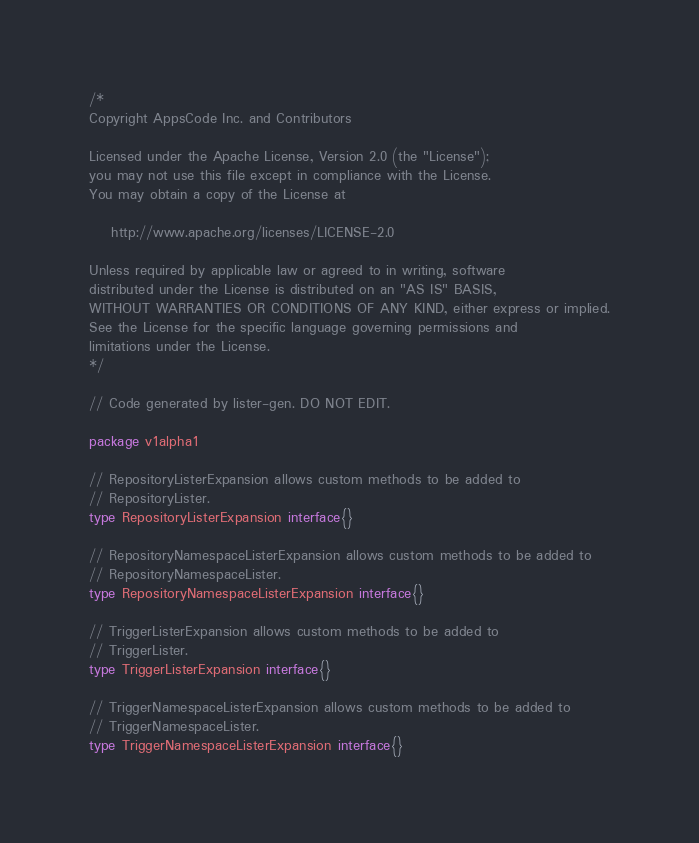Convert code to text. <code><loc_0><loc_0><loc_500><loc_500><_Go_>/*
Copyright AppsCode Inc. and Contributors

Licensed under the Apache License, Version 2.0 (the "License");
you may not use this file except in compliance with the License.
You may obtain a copy of the License at

    http://www.apache.org/licenses/LICENSE-2.0

Unless required by applicable law or agreed to in writing, software
distributed under the License is distributed on an "AS IS" BASIS,
WITHOUT WARRANTIES OR CONDITIONS OF ANY KIND, either express or implied.
See the License for the specific language governing permissions and
limitations under the License.
*/

// Code generated by lister-gen. DO NOT EDIT.

package v1alpha1

// RepositoryListerExpansion allows custom methods to be added to
// RepositoryLister.
type RepositoryListerExpansion interface{}

// RepositoryNamespaceListerExpansion allows custom methods to be added to
// RepositoryNamespaceLister.
type RepositoryNamespaceListerExpansion interface{}

// TriggerListerExpansion allows custom methods to be added to
// TriggerLister.
type TriggerListerExpansion interface{}

// TriggerNamespaceListerExpansion allows custom methods to be added to
// TriggerNamespaceLister.
type TriggerNamespaceListerExpansion interface{}
</code> 